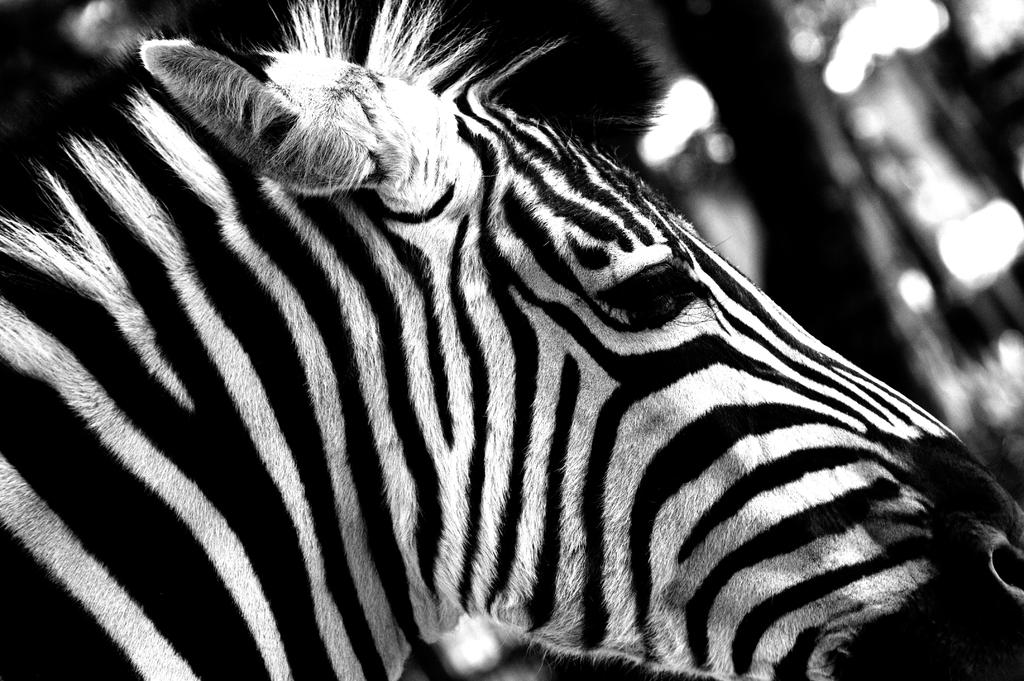What animal is the main subject of the picture? There is a zebra in the picture. How would you describe the background of the image? The background of the image is blurred. What color scheme is used in the image? The image is black and white in color. What type of underwear is the zebra wearing in the image? There is no underwear present in the image, as it features a zebra in a black and white setting with a blurred background. 